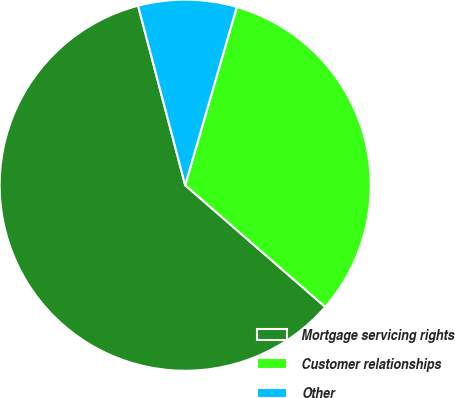Convert chart to OTSL. <chart><loc_0><loc_0><loc_500><loc_500><pie_chart><fcel>Mortgage servicing rights<fcel>Customer relationships<fcel>Other<nl><fcel>59.52%<fcel>31.9%<fcel>8.57%<nl></chart> 